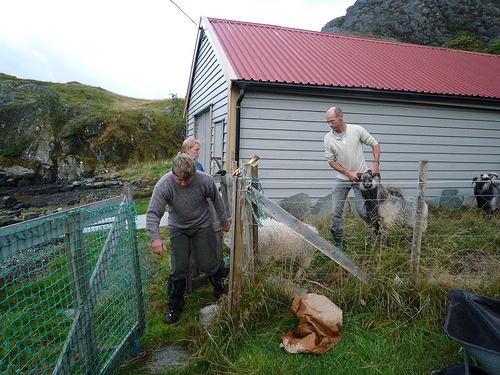<image>
Can you confirm if the building is next to the wall? No. The building is not positioned next to the wall. They are located in different areas of the scene. 